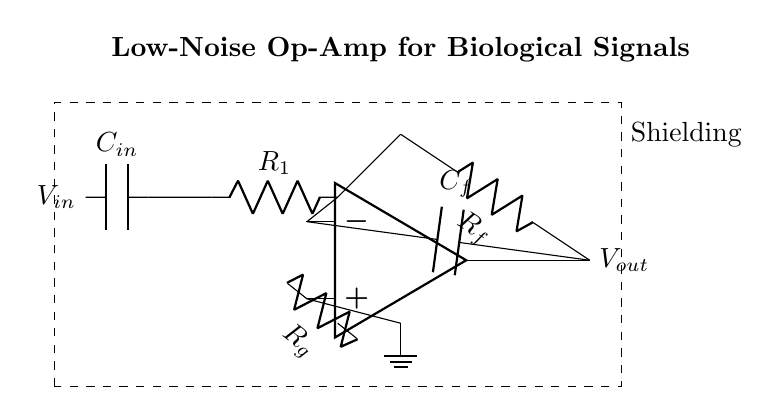What is the role of C_in? C_in acts as a coupling capacitor to filter out DC components from the input signal, allowing only AC signals to pass. This is important for biological signal measurements, which are often small AC signals superimposed on a DC offset.
Answer: Coupling What is the feedback resistor labeled as? The resistor connected in the feedback loop is labeled as R_f, which defines the gain of the operational amplifier by providing feedback from the output to the inverting input.
Answer: R_f Which component is used for noise reduction in the circuit? The capacitor labeled C_f in the feedback loop helps to reduce high-frequency noise, improving the signal integrity and measurement reliability.
Answer: C_f How is the operational amplifier powered? The operational amplifier's non-inverting input is grounded, which is often a reference voltage level, providing a stable operating condition and setting the input bias for the amplifier.
Answer: Grounded What is the purpose of R_g? R_g serves as a gain-setting resistor connected to the non-inverting terminal of the op-amp, influencing the overall gain of the circuit by determining the amount of input signal gain in conjunction with R_f.
Answer: Gain-setting What type of circuit is this? The circuit is classified as a low-noise operational amplifier circuit specifically designed for the precise measurement of biological signals, emphasizing signal clarity and minimal noise interference.
Answer: Amplifier 